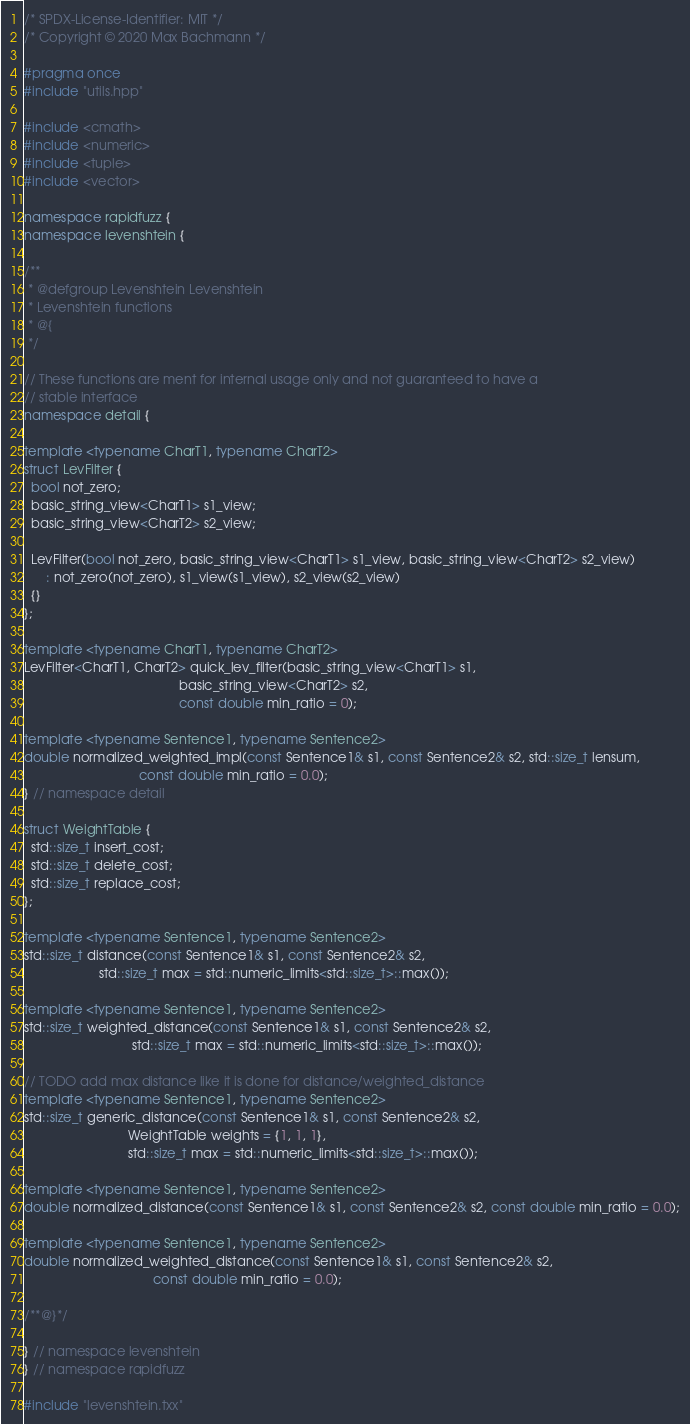Convert code to text. <code><loc_0><loc_0><loc_500><loc_500><_C++_>/* SPDX-License-Identifier: MIT */
/* Copyright © 2020 Max Bachmann */

#pragma once
#include "utils.hpp"

#include <cmath>
#include <numeric>
#include <tuple>
#include <vector>

namespace rapidfuzz {
namespace levenshtein {

/**
 * @defgroup Levenshtein Levenshtein
 * Levenshtein functions
 * @{
 */

// These functions are ment for internal usage only and not guaranteed to have a
// stable interface
namespace detail {

template <typename CharT1, typename CharT2>
struct LevFilter {
  bool not_zero;
  basic_string_view<CharT1> s1_view;
  basic_string_view<CharT2> s2_view;

  LevFilter(bool not_zero, basic_string_view<CharT1> s1_view, basic_string_view<CharT2> s2_view)
      : not_zero(not_zero), s1_view(s1_view), s2_view(s2_view)
  {}
};

template <typename CharT1, typename CharT2>
LevFilter<CharT1, CharT2> quick_lev_filter(basic_string_view<CharT1> s1,
                                           basic_string_view<CharT2> s2,
                                           const double min_ratio = 0);

template <typename Sentence1, typename Sentence2>
double normalized_weighted_impl(const Sentence1& s1, const Sentence2& s2, std::size_t lensum,
                                const double min_ratio = 0.0);
} // namespace detail

struct WeightTable {
  std::size_t insert_cost;
  std::size_t delete_cost;
  std::size_t replace_cost;
};

template <typename Sentence1, typename Sentence2>
std::size_t distance(const Sentence1& s1, const Sentence2& s2,
                     std::size_t max = std::numeric_limits<std::size_t>::max());

template <typename Sentence1, typename Sentence2>
std::size_t weighted_distance(const Sentence1& s1, const Sentence2& s2,
                              std::size_t max = std::numeric_limits<std::size_t>::max());

// TODO add max distance like it is done for distance/weighted_distance
template <typename Sentence1, typename Sentence2>
std::size_t generic_distance(const Sentence1& s1, const Sentence2& s2,
                             WeightTable weights = {1, 1, 1},
                             std::size_t max = std::numeric_limits<std::size_t>::max());

template <typename Sentence1, typename Sentence2>
double normalized_distance(const Sentence1& s1, const Sentence2& s2, const double min_ratio = 0.0);

template <typename Sentence1, typename Sentence2>
double normalized_weighted_distance(const Sentence1& s1, const Sentence2& s2,
                                    const double min_ratio = 0.0);

/**@}*/

} // namespace levenshtein
} // namespace rapidfuzz

#include "levenshtein.txx"
</code> 